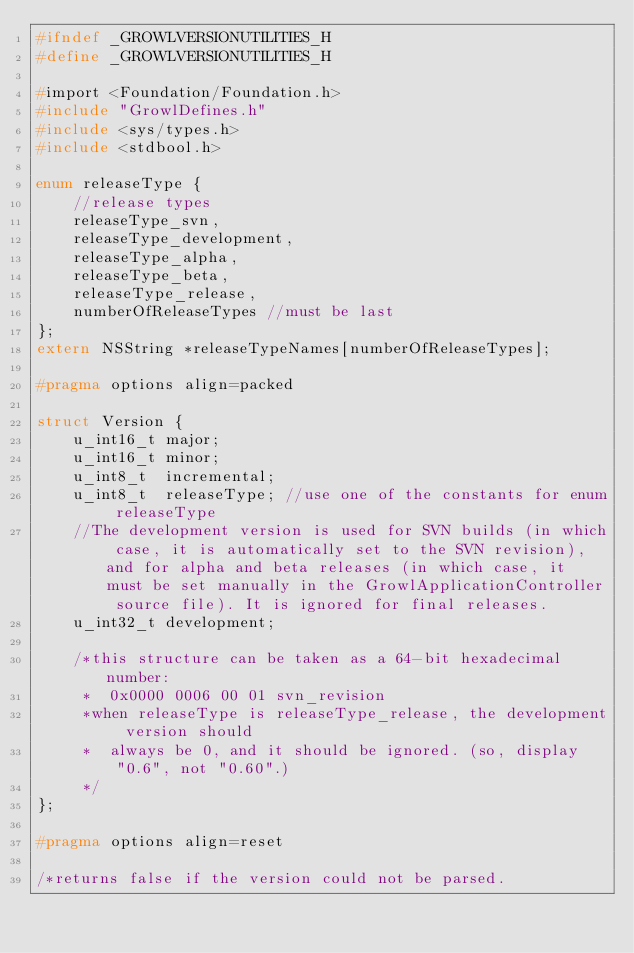<code> <loc_0><loc_0><loc_500><loc_500><_C_>#ifndef _GROWLVERSIONUTILITIES_H
#define _GROWLVERSIONUTILITIES_H

#import <Foundation/Foundation.h>
#include "GrowlDefines.h"
#include <sys/types.h>
#include <stdbool.h>

enum releaseType {
	//release types
	releaseType_svn,
	releaseType_development,
	releaseType_alpha,
	releaseType_beta,
	releaseType_release,
	numberOfReleaseTypes //must be last
};
extern NSString *releaseTypeNames[numberOfReleaseTypes];

#pragma options align=packed

struct Version {
	u_int16_t major;
	u_int16_t minor;
	u_int8_t  incremental;
	u_int8_t  releaseType; //use one of the constants for enum releaseType
	//The development version is used for SVN builds (in which case, it is automatically set to the SVN revision), and for alpha and beta releases (in which case, it must be set manually in the GrowlApplicationController source file). It is ignored for final releases.
	u_int32_t development;

	/*this structure can be taken as a 64-bit hexadecimal number:
	 *	0x0000 0006 00 01 svn_revision
	 *when releaseType is releaseType_release, the development version should
	 *	always be 0, and it should be ignored. (so, display "0.6", not "0.60".)
	 */
};

#pragma options align=reset

/*returns false if the version could not be parsed.</code> 